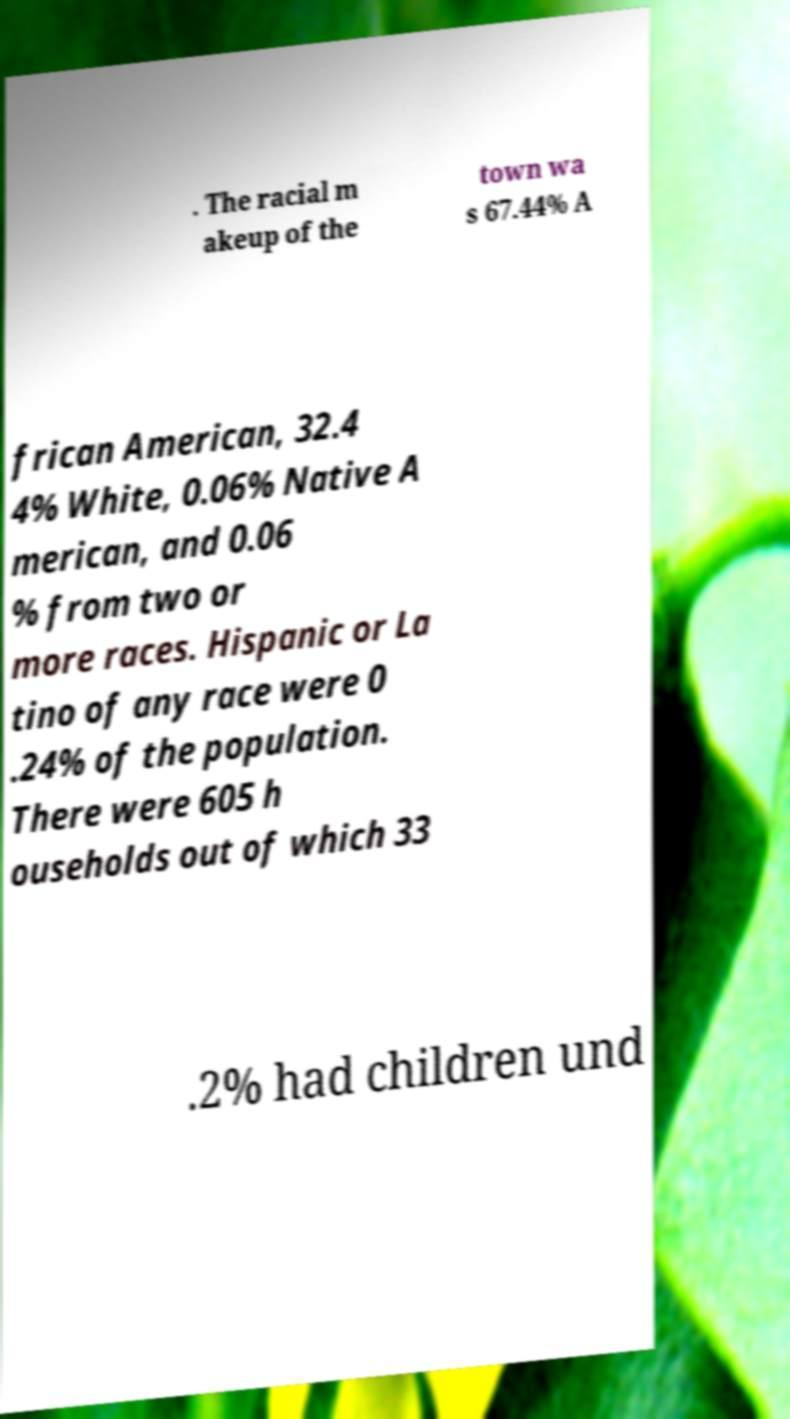Could you extract and type out the text from this image? . The racial m akeup of the town wa s 67.44% A frican American, 32.4 4% White, 0.06% Native A merican, and 0.06 % from two or more races. Hispanic or La tino of any race were 0 .24% of the population. There were 605 h ouseholds out of which 33 .2% had children und 